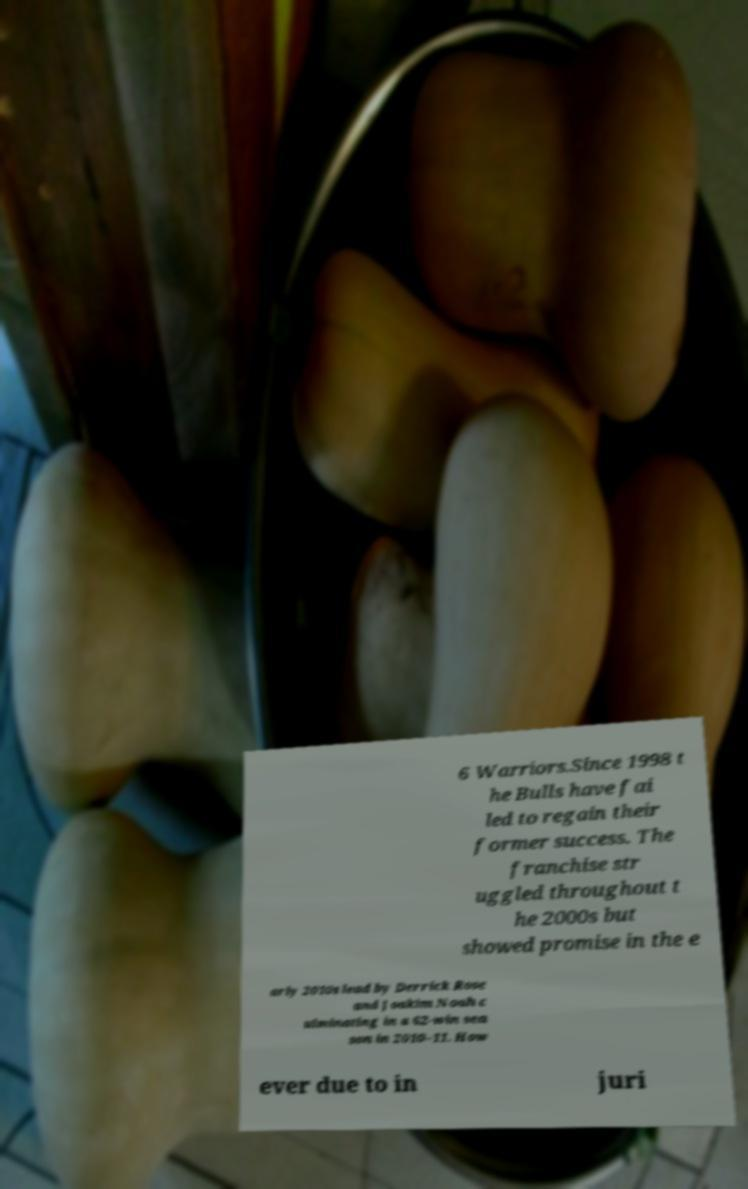Please read and relay the text visible in this image. What does it say? 6 Warriors.Since 1998 t he Bulls have fai led to regain their former success. The franchise str uggled throughout t he 2000s but showed promise in the e arly 2010s lead by Derrick Rose and Joakim Noah c ulminating in a 62-win sea son in 2010–11. How ever due to in juri 